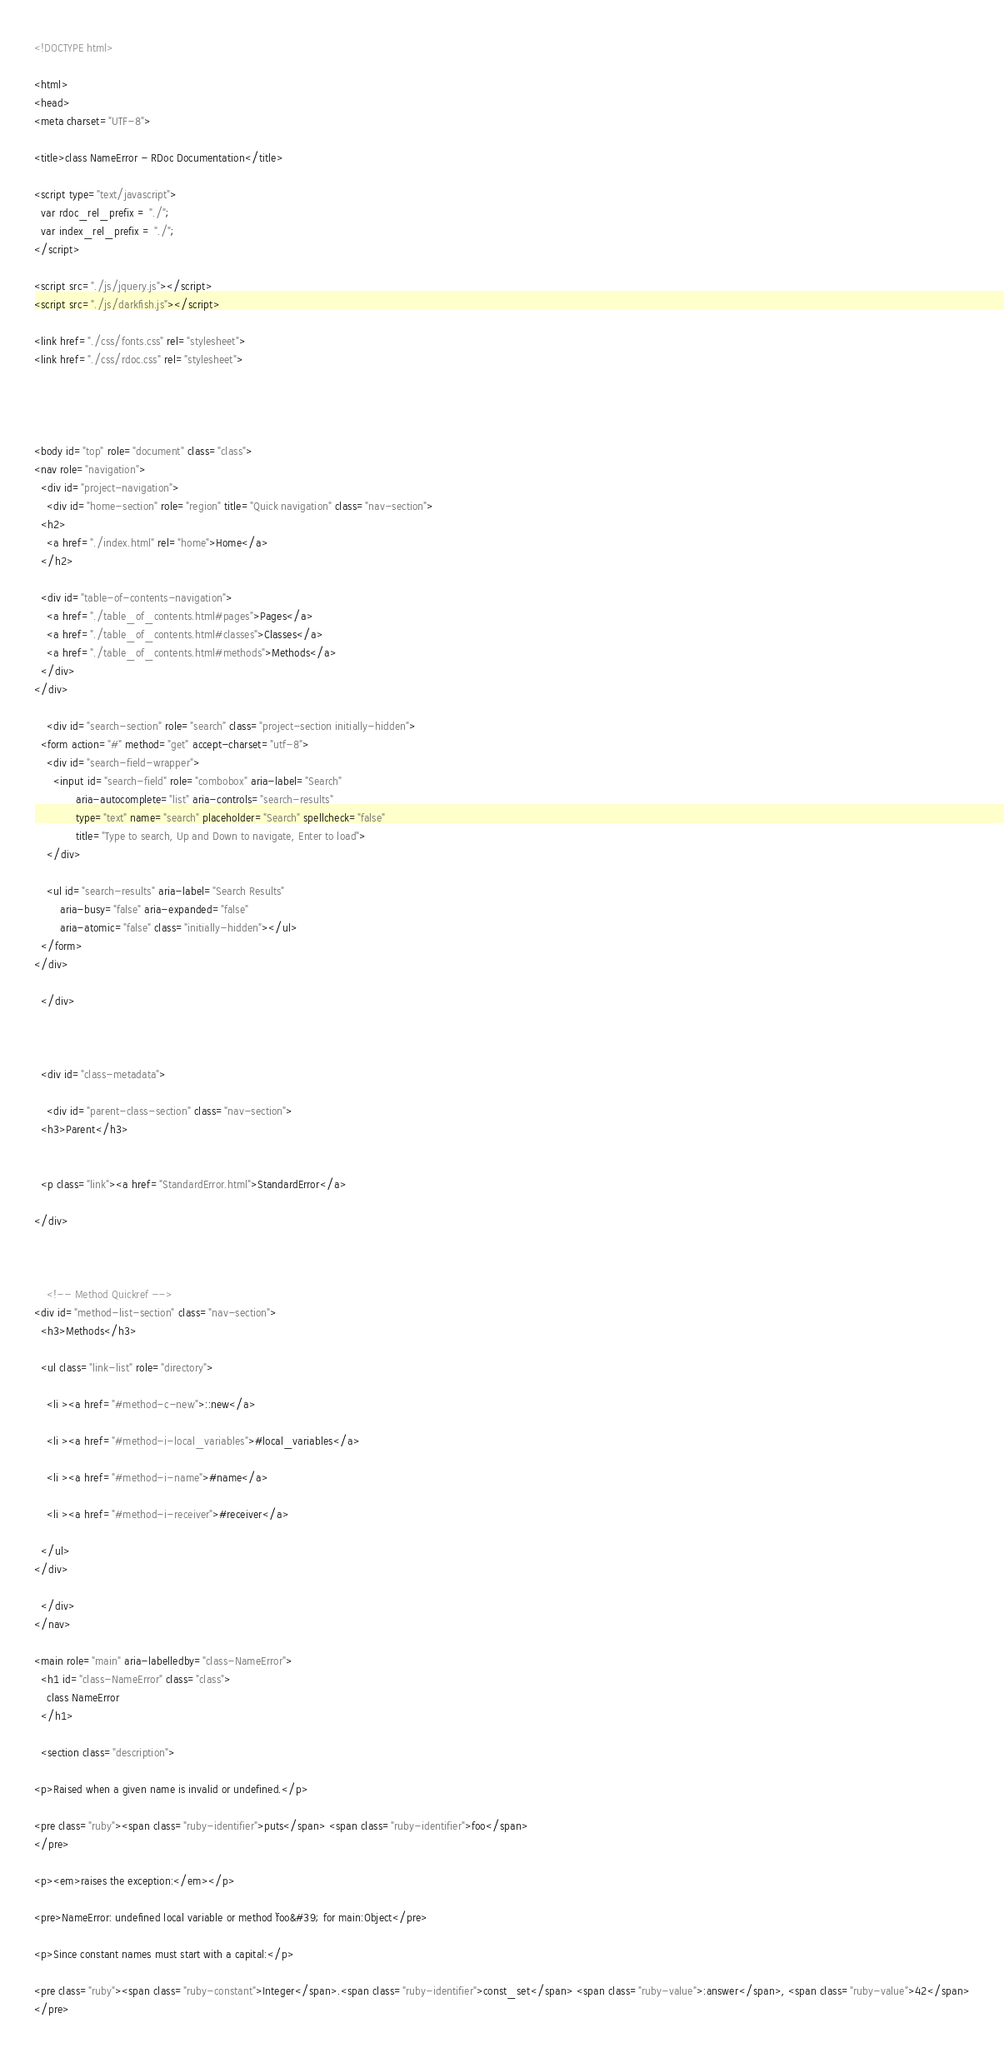<code> <loc_0><loc_0><loc_500><loc_500><_HTML_><!DOCTYPE html>

<html>
<head>
<meta charset="UTF-8">

<title>class NameError - RDoc Documentation</title>

<script type="text/javascript">
  var rdoc_rel_prefix = "./";
  var index_rel_prefix = "./";
</script>

<script src="./js/jquery.js"></script>
<script src="./js/darkfish.js"></script>

<link href="./css/fonts.css" rel="stylesheet">
<link href="./css/rdoc.css" rel="stylesheet">




<body id="top" role="document" class="class">
<nav role="navigation">
  <div id="project-navigation">
    <div id="home-section" role="region" title="Quick navigation" class="nav-section">
  <h2>
    <a href="./index.html" rel="home">Home</a>
  </h2>

  <div id="table-of-contents-navigation">
    <a href="./table_of_contents.html#pages">Pages</a>
    <a href="./table_of_contents.html#classes">Classes</a>
    <a href="./table_of_contents.html#methods">Methods</a>
  </div>
</div>

    <div id="search-section" role="search" class="project-section initially-hidden">
  <form action="#" method="get" accept-charset="utf-8">
    <div id="search-field-wrapper">
      <input id="search-field" role="combobox" aria-label="Search"
             aria-autocomplete="list" aria-controls="search-results"
             type="text" name="search" placeholder="Search" spellcheck="false"
             title="Type to search, Up and Down to navigate, Enter to load">
    </div>

    <ul id="search-results" aria-label="Search Results"
        aria-busy="false" aria-expanded="false"
        aria-atomic="false" class="initially-hidden"></ul>
  </form>
</div>

  </div>

  

  <div id="class-metadata">
    
    <div id="parent-class-section" class="nav-section">
  <h3>Parent</h3>

  
  <p class="link"><a href="StandardError.html">StandardError</a>
  
</div>

    
    
    <!-- Method Quickref -->
<div id="method-list-section" class="nav-section">
  <h3>Methods</h3>

  <ul class="link-list" role="directory">
    
    <li ><a href="#method-c-new">::new</a>
    
    <li ><a href="#method-i-local_variables">#local_variables</a>
    
    <li ><a href="#method-i-name">#name</a>
    
    <li ><a href="#method-i-receiver">#receiver</a>
    
  </ul>
</div>

  </div>
</nav>

<main role="main" aria-labelledby="class-NameError">
  <h1 id="class-NameError" class="class">
    class NameError
  </h1>

  <section class="description">
    
<p>Raised when a given name is invalid or undefined.</p>

<pre class="ruby"><span class="ruby-identifier">puts</span> <span class="ruby-identifier">foo</span>
</pre>

<p><em>raises the exception:</em></p>

<pre>NameError: undefined local variable or method `foo&#39; for main:Object</pre>

<p>Since constant names must start with a capital:</p>

<pre class="ruby"><span class="ruby-constant">Integer</span>.<span class="ruby-identifier">const_set</span> <span class="ruby-value">:answer</span>, <span class="ruby-value">42</span>
</pre>
</code> 